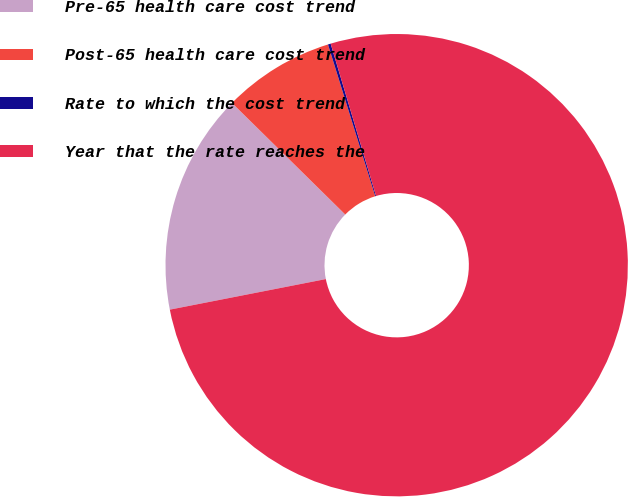<chart> <loc_0><loc_0><loc_500><loc_500><pie_chart><fcel>Pre-65 health care cost trend<fcel>Post-65 health care cost trend<fcel>Rate to which the cost trend<fcel>Year that the rate reaches the<nl><fcel>15.46%<fcel>7.82%<fcel>0.19%<fcel>76.53%<nl></chart> 